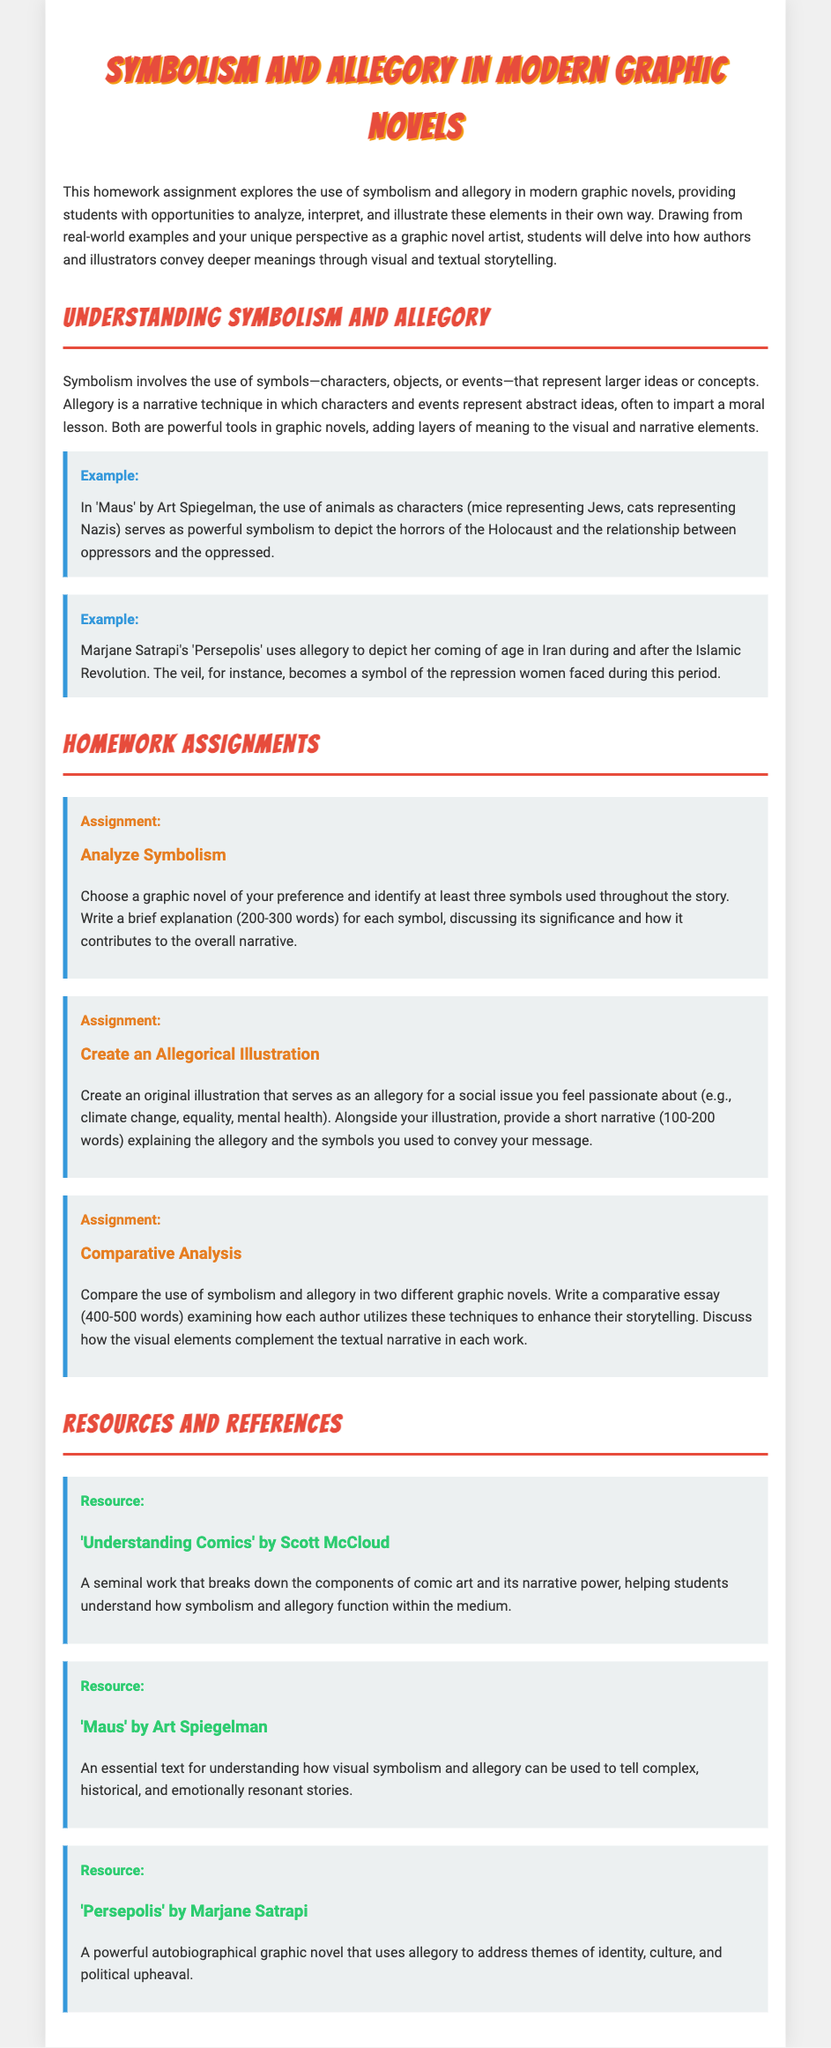What is the title of the homework assignment? The title is stated prominently at the top of the document, indicating the main focus of the assignment.
Answer: Symbolism and Allegory in Modern Graphic Novels Who is the author of 'Maus'? The document provides an example from 'Maus' and attributes it to Art Spiegelman as the author.
Answer: Art Spiegelman What social issue should be addressed in the allegorical illustration assignment? The assignment specifies a range of social issues, giving students direction for their illustration.
Answer: climate change, equality, mental health How many graphic novels should be analyzed in the comparative essay? The comparative analysis assignment clearly states the requirement for the number of graphic novels to be examined.
Answer: two What is a key theme discussed in 'Persepolis'? The document highlights the themes addressed in 'Persepolis' through the context of allegory.
Answer: identity, culture, political upheaval How many words should the explanation for each symbol have in the analysis assignment? The requirements for the word count are specified in the assignment for clarity.
Answer: 200-300 words What are the two types of literary devices emphasized in this homework assignment? The introduction section defines the two main concepts being explored in the homework, outlining their significance.
Answer: symbolism, allegory What is the purpose of using animals as characters in 'Maus'? The example illustrates how characters are symbolically represented in the graphic novel.
Answer: depict the horrors of the Holocaust What book is recommended for understanding the components of comic art? The resource section lists a book that provides insight into comic artistry, enhancing understanding of the medium.
Answer: Understanding Comics 